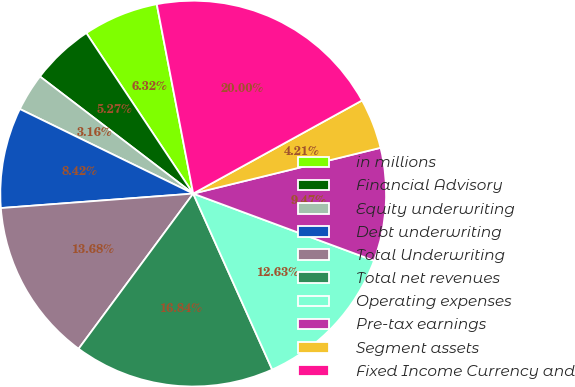Convert chart. <chart><loc_0><loc_0><loc_500><loc_500><pie_chart><fcel>in millions<fcel>Financial Advisory<fcel>Equity underwriting<fcel>Debt underwriting<fcel>Total Underwriting<fcel>Total net revenues<fcel>Operating expenses<fcel>Pre-tax earnings<fcel>Segment assets<fcel>Fixed Income Currency and<nl><fcel>6.32%<fcel>5.27%<fcel>3.16%<fcel>8.42%<fcel>13.68%<fcel>16.84%<fcel>12.63%<fcel>9.47%<fcel>4.21%<fcel>20.0%<nl></chart> 